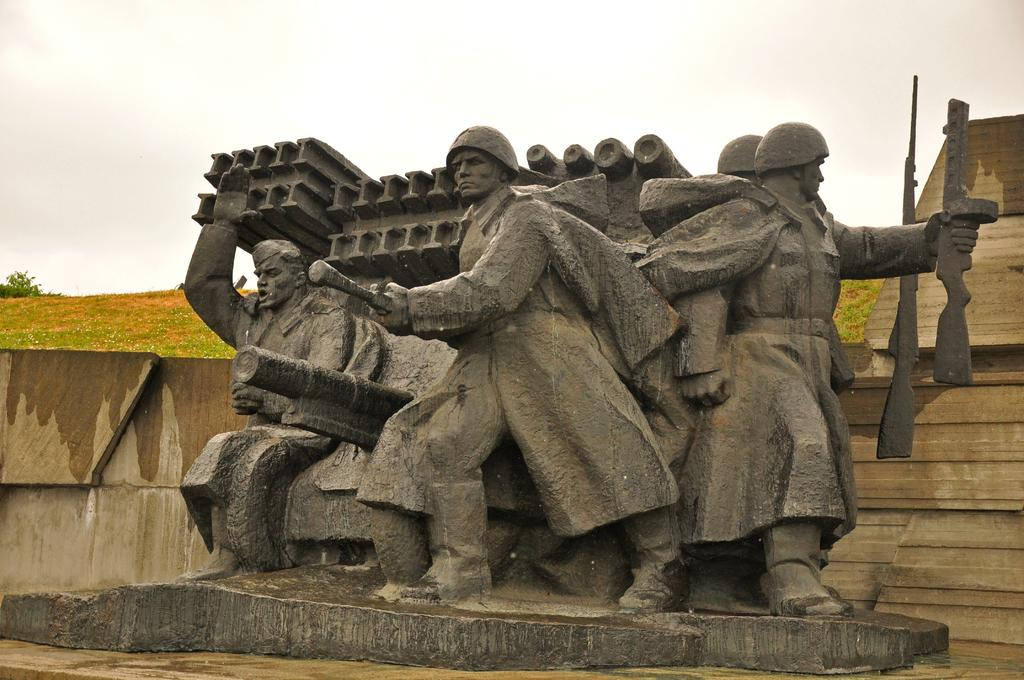What is the main subject of the image? There is a sculpture in the image. What does the sculpture depict? The sculpture represents people holding objects in their hands. What can be seen in the background of the image? There is a wall in the background of the image. What is visible at the top of the image? The sky is visible at the top of the image. What type of birthday celebration is depicted in the image? There is no birthday celebration depicted in the image; it features a sculpture of people holding objects in their hands. Can you see a bird balancing on the sculpture in the image? There is no bird present in the image, and therefore no such balancing act can be observed. 